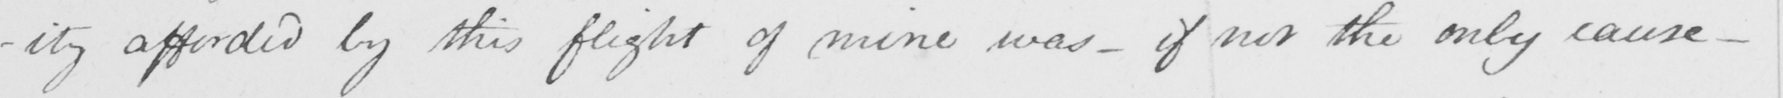Please transcribe the handwritten text in this image. -ity afforded by this flight of mine was  _  if not the only cause  _ 